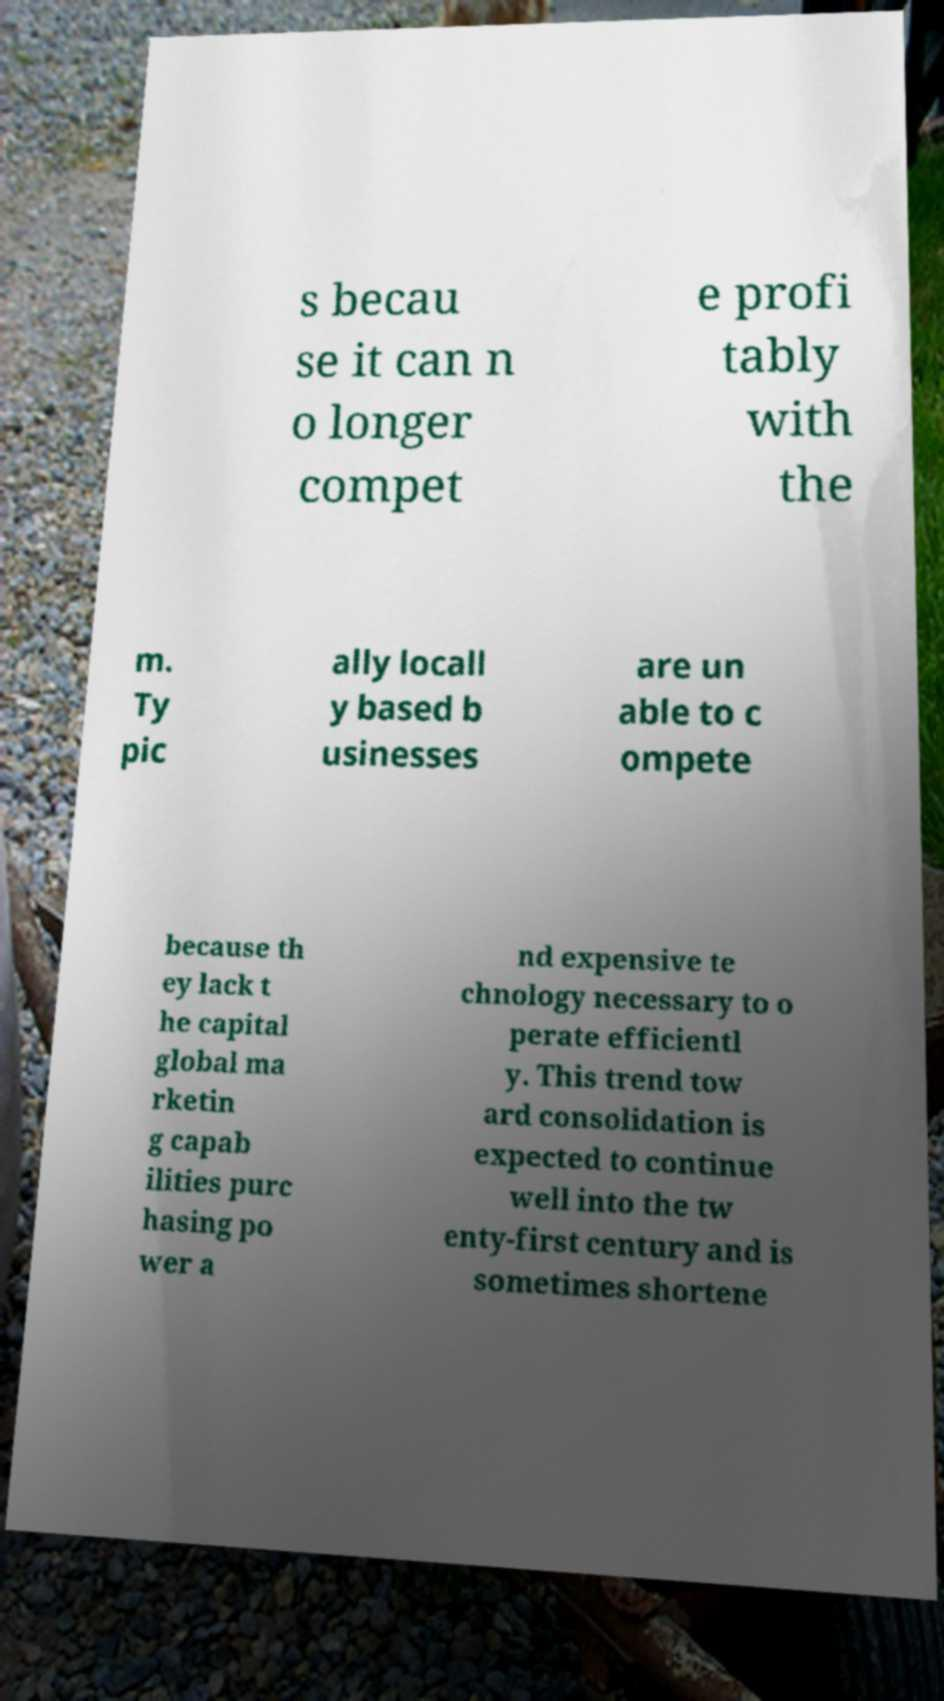Could you assist in decoding the text presented in this image and type it out clearly? s becau se it can n o longer compet e profi tably with the m. Ty pic ally locall y based b usinesses are un able to c ompete because th ey lack t he capital global ma rketin g capab ilities purc hasing po wer a nd expensive te chnology necessary to o perate efficientl y. This trend tow ard consolidation is expected to continue well into the tw enty-first century and is sometimes shortene 